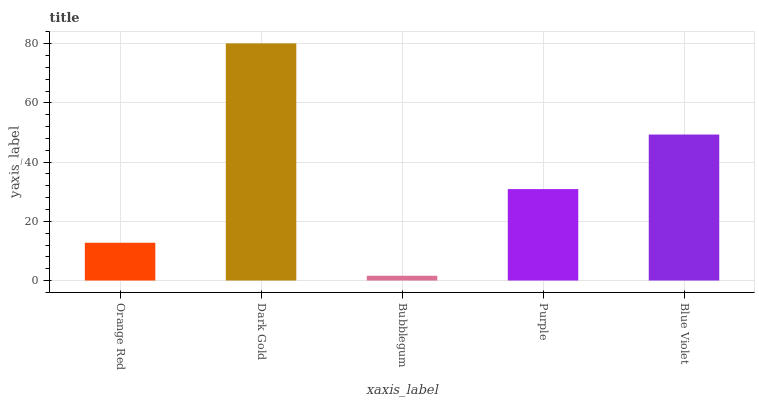Is Bubblegum the minimum?
Answer yes or no. Yes. Is Dark Gold the maximum?
Answer yes or no. Yes. Is Dark Gold the minimum?
Answer yes or no. No. Is Bubblegum the maximum?
Answer yes or no. No. Is Dark Gold greater than Bubblegum?
Answer yes or no. Yes. Is Bubblegum less than Dark Gold?
Answer yes or no. Yes. Is Bubblegum greater than Dark Gold?
Answer yes or no. No. Is Dark Gold less than Bubblegum?
Answer yes or no. No. Is Purple the high median?
Answer yes or no. Yes. Is Purple the low median?
Answer yes or no. Yes. Is Orange Red the high median?
Answer yes or no. No. Is Bubblegum the low median?
Answer yes or no. No. 